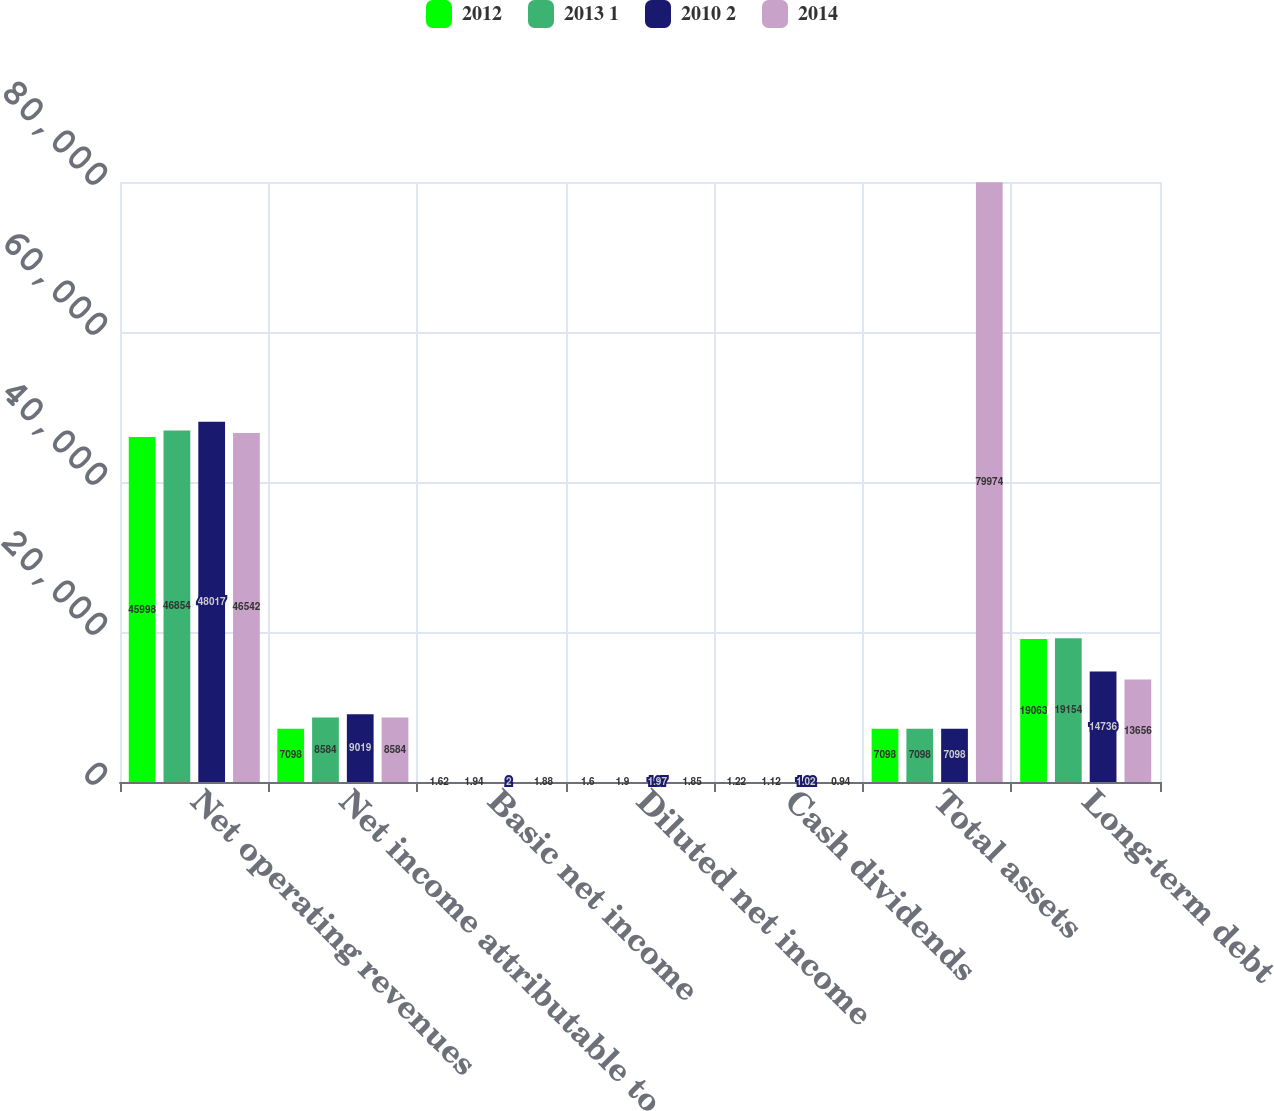<chart> <loc_0><loc_0><loc_500><loc_500><stacked_bar_chart><ecel><fcel>Net operating revenues<fcel>Net income attributable to<fcel>Basic net income<fcel>Diluted net income<fcel>Cash dividends<fcel>Total assets<fcel>Long-term debt<nl><fcel>2012<fcel>45998<fcel>7098<fcel>1.62<fcel>1.6<fcel>1.22<fcel>7098<fcel>19063<nl><fcel>2013 1<fcel>46854<fcel>8584<fcel>1.94<fcel>1.9<fcel>1.12<fcel>7098<fcel>19154<nl><fcel>2010 2<fcel>48017<fcel>9019<fcel>2<fcel>1.97<fcel>1.02<fcel>7098<fcel>14736<nl><fcel>2014<fcel>46542<fcel>8584<fcel>1.88<fcel>1.85<fcel>0.94<fcel>79974<fcel>13656<nl></chart> 